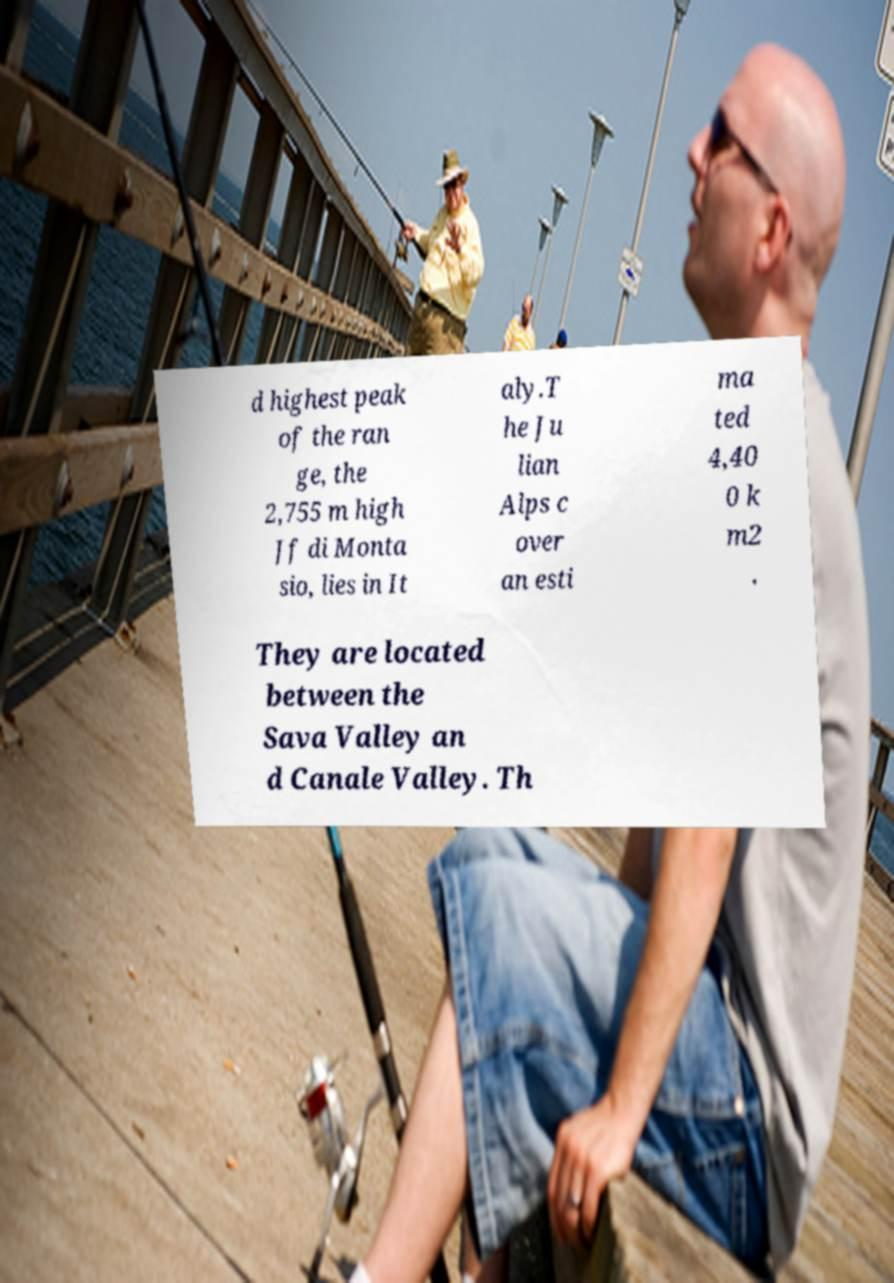Could you assist in decoding the text presented in this image and type it out clearly? d highest peak of the ran ge, the 2,755 m high Jf di Monta sio, lies in It aly.T he Ju lian Alps c over an esti ma ted 4,40 0 k m2 . They are located between the Sava Valley an d Canale Valley. Th 